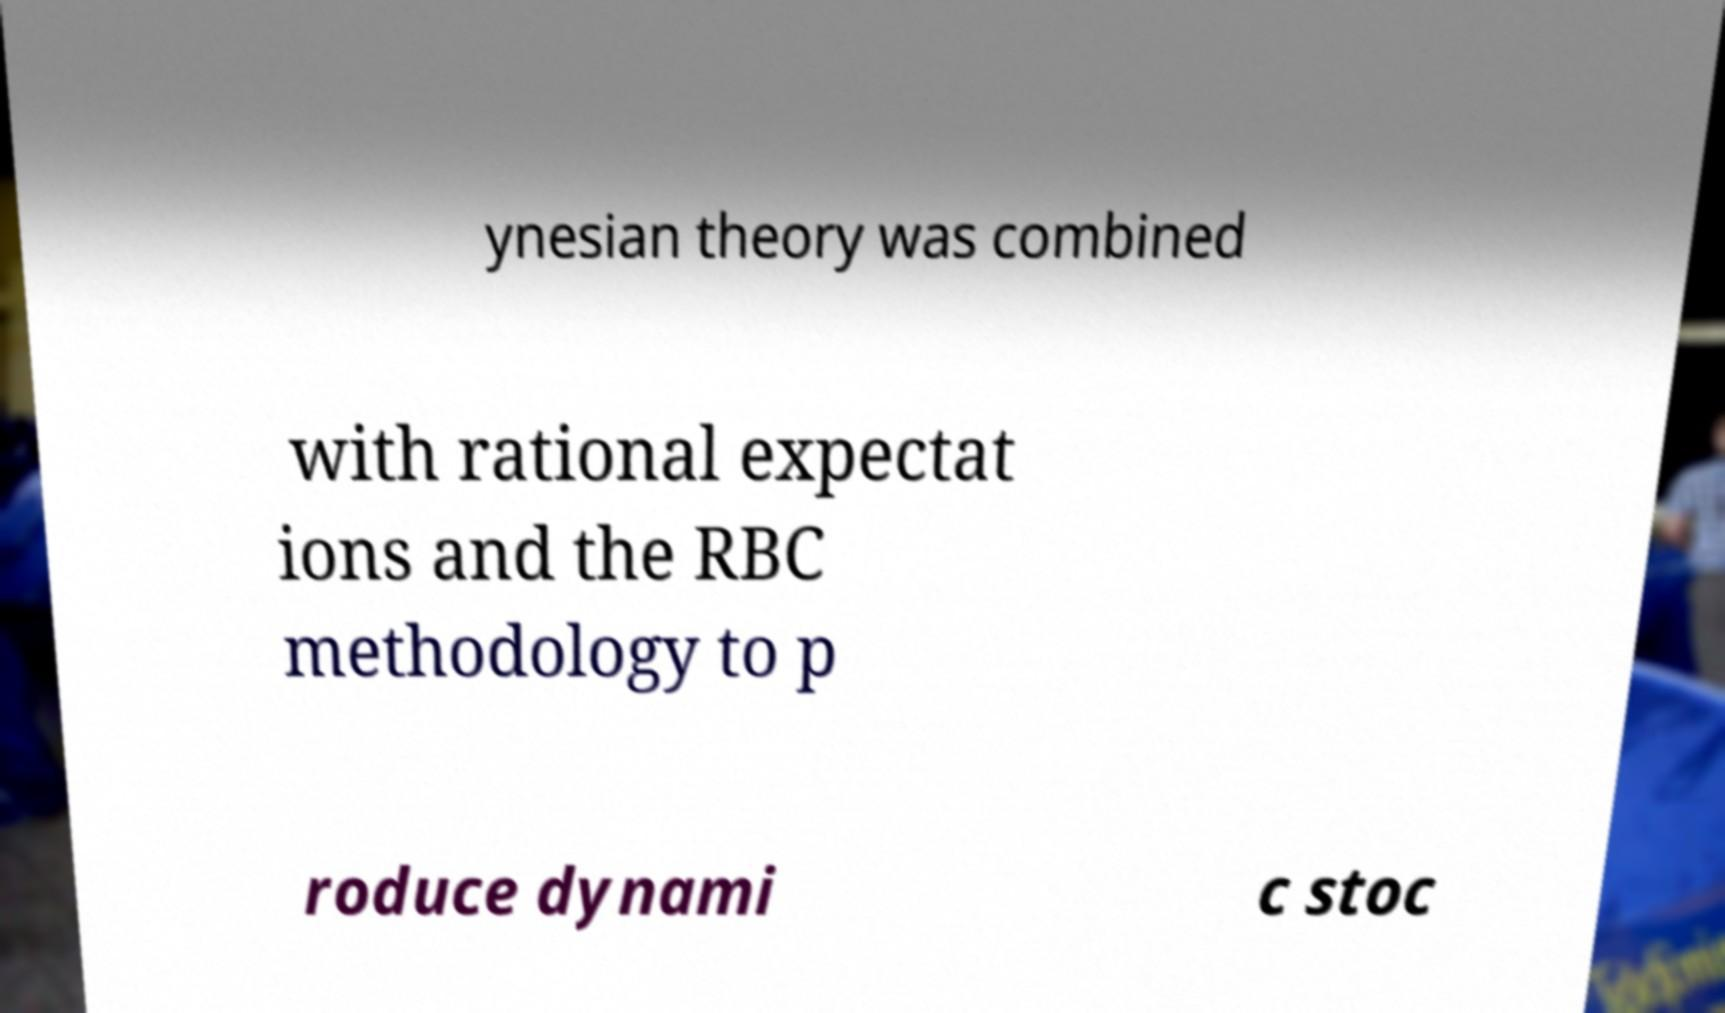Can you read and provide the text displayed in the image?This photo seems to have some interesting text. Can you extract and type it out for me? ynesian theory was combined with rational expectat ions and the RBC methodology to p roduce dynami c stoc 